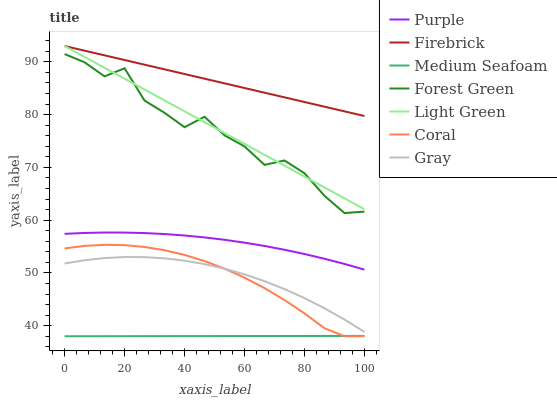Does Medium Seafoam have the minimum area under the curve?
Answer yes or no. Yes. Does Firebrick have the maximum area under the curve?
Answer yes or no. Yes. Does Purple have the minimum area under the curve?
Answer yes or no. No. Does Purple have the maximum area under the curve?
Answer yes or no. No. Is Medium Seafoam the smoothest?
Answer yes or no. Yes. Is Forest Green the roughest?
Answer yes or no. Yes. Is Purple the smoothest?
Answer yes or no. No. Is Purple the roughest?
Answer yes or no. No. Does Medium Seafoam have the lowest value?
Answer yes or no. Yes. Does Purple have the lowest value?
Answer yes or no. No. Does Light Green have the highest value?
Answer yes or no. Yes. Does Purple have the highest value?
Answer yes or no. No. Is Coral less than Forest Green?
Answer yes or no. Yes. Is Light Green greater than Medium Seafoam?
Answer yes or no. Yes. Does Gray intersect Coral?
Answer yes or no. Yes. Is Gray less than Coral?
Answer yes or no. No. Is Gray greater than Coral?
Answer yes or no. No. Does Coral intersect Forest Green?
Answer yes or no. No. 